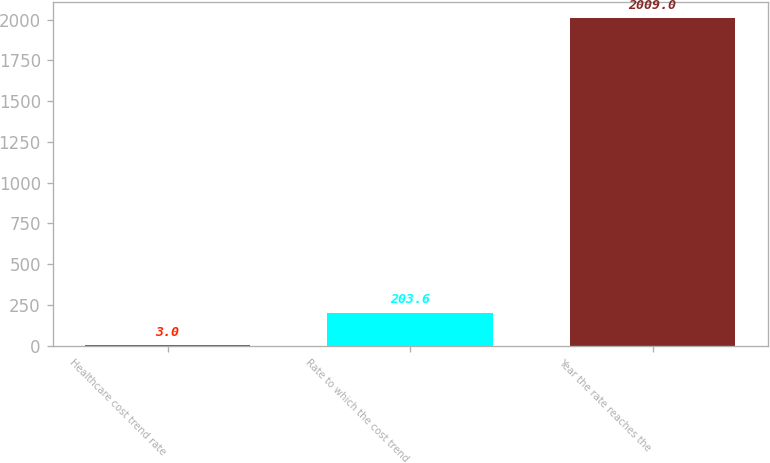<chart> <loc_0><loc_0><loc_500><loc_500><bar_chart><fcel>Healthcare cost trend rate<fcel>Rate to which the cost trend<fcel>Year the rate reaches the<nl><fcel>3<fcel>203.6<fcel>2009<nl></chart> 